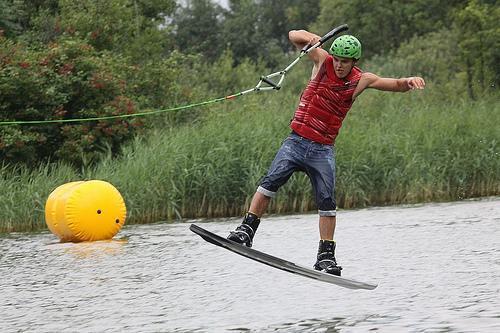How many items are currently floating on the water?
Give a very brief answer. 1. How many people are in the photo?
Give a very brief answer. 1. 